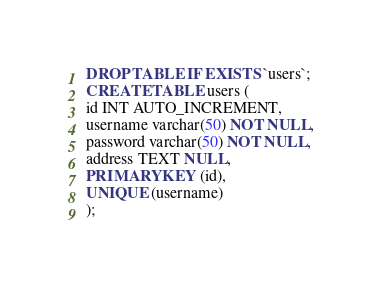<code> <loc_0><loc_0><loc_500><loc_500><_SQL_>
DROP TABLE IF EXISTS `users`;
CREATE TABLE users (
id INT AUTO_INCREMENT,
username varchar(50) NOT NULL,
password varchar(50) NOT NULL,
address TEXT NULL,
PRIMARY KEY (id),
UNIQUE (username)
);

</code> 